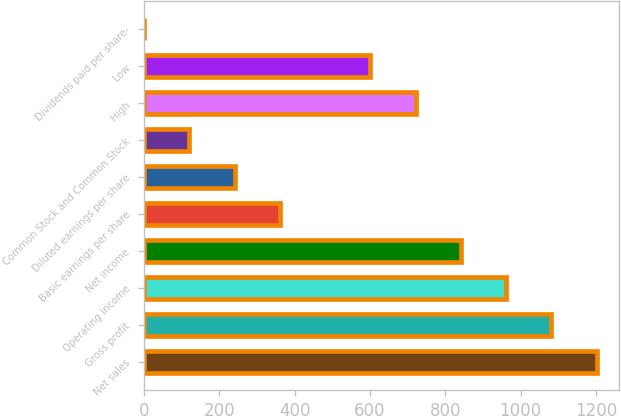<chart> <loc_0><loc_0><loc_500><loc_500><bar_chart><fcel>Net sales<fcel>Gross profit<fcel>Operating income<fcel>Net income<fcel>Basic earnings per share<fcel>Diluted earnings per share<fcel>Common Stock and Common Stock<fcel>High<fcel>Low<fcel>Dividends paid per share-<nl><fcel>1201.9<fcel>1081.72<fcel>961.57<fcel>841.42<fcel>360.82<fcel>240.67<fcel>120.52<fcel>721.27<fcel>601.12<fcel>0.37<nl></chart> 